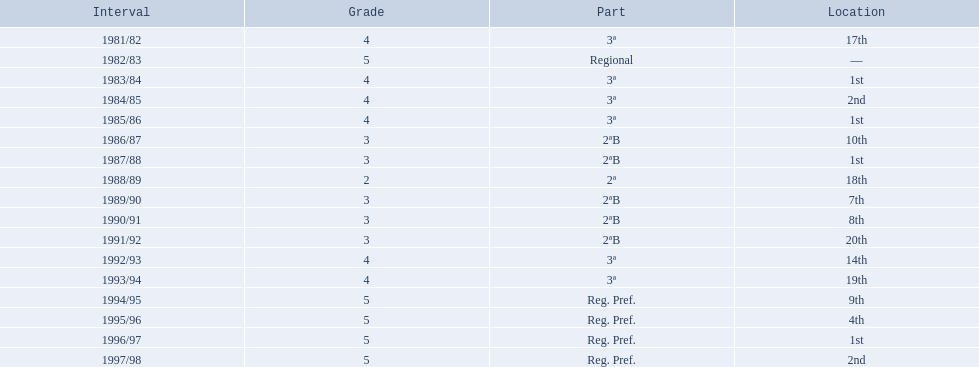In what years did the team finish 17th or worse? 1981/82, 1988/89, 1991/92, 1993/94. Of those, in which year the team finish worse? 1991/92. 